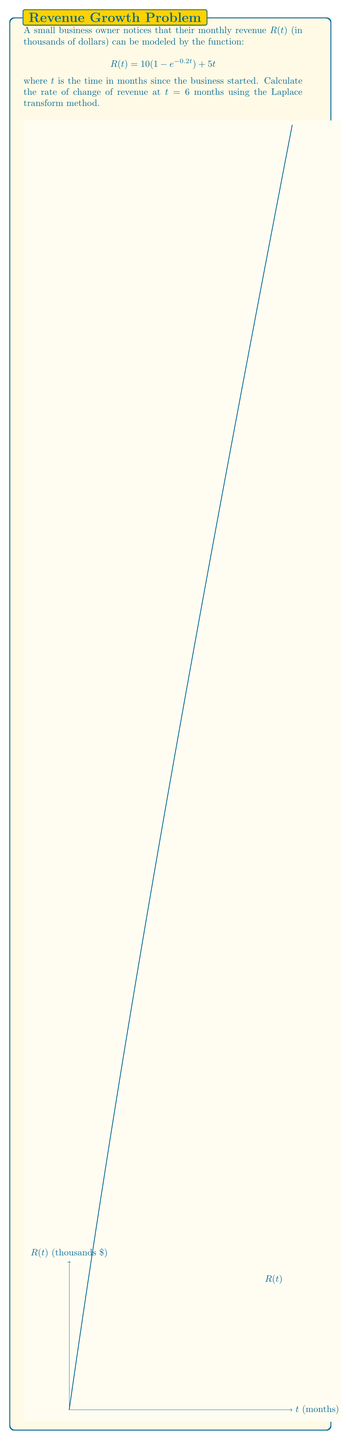Help me with this question. Let's approach this step-by-step using the Laplace transform method:

1) First, we need to find the Laplace transform of $R(t)$:
   $$\mathcal{L}\{R(t)\} = \mathcal{L}\{10(1 - e^{-0.2t}) + 5t\}$$

2) Using linearity and standard Laplace transform pairs:
   $$\mathcal{L}\{R(t)\} = 10\mathcal{L}\{1\} - 10\mathcal{L}\{e^{-0.2t}\} + 5\mathcal{L}\{t\}$$
   $$= \frac{10}{s} - \frac{10}{s+0.2} + \frac{5}{s^2}$$

3) To find the rate of change, we need to differentiate $R(t)$ with respect to $t$. In the s-domain, this is equivalent to multiplying by $s$ and subtracting the initial value:
   $$\mathcal{L}\{R'(t)\} = s\mathcal{L}\{R(t)\} - R(0)$$
   $$= s(\frac{10}{s} - \frac{10}{s+0.2} + \frac{5}{s^2}) - 0$$
   $$= 10 - \frac{10s}{s+0.2} + \frac{5}{s}$$

4) Now we need to find the inverse Laplace transform:
   $$R'(t) = \mathcal{L}^{-1}\{10 - \frac{10s}{s+0.2} + \frac{5}{s}\}$$
   $$= 10 - 10e^{-0.2t} + 5$$

5) To find the rate of change at $t = 6$, we substitute $t = 6$ into this expression:
   $$R'(6) = 10 - 10e^{-0.2(6)} + 5$$
   $$= 15 - 10e^{-1.2}$$
   $$\approx 11.98$$

Therefore, the rate of change of revenue at 6 months is approximately 11.98 thousand dollars per month.
Answer: $11.98$ thousand dollars per month 